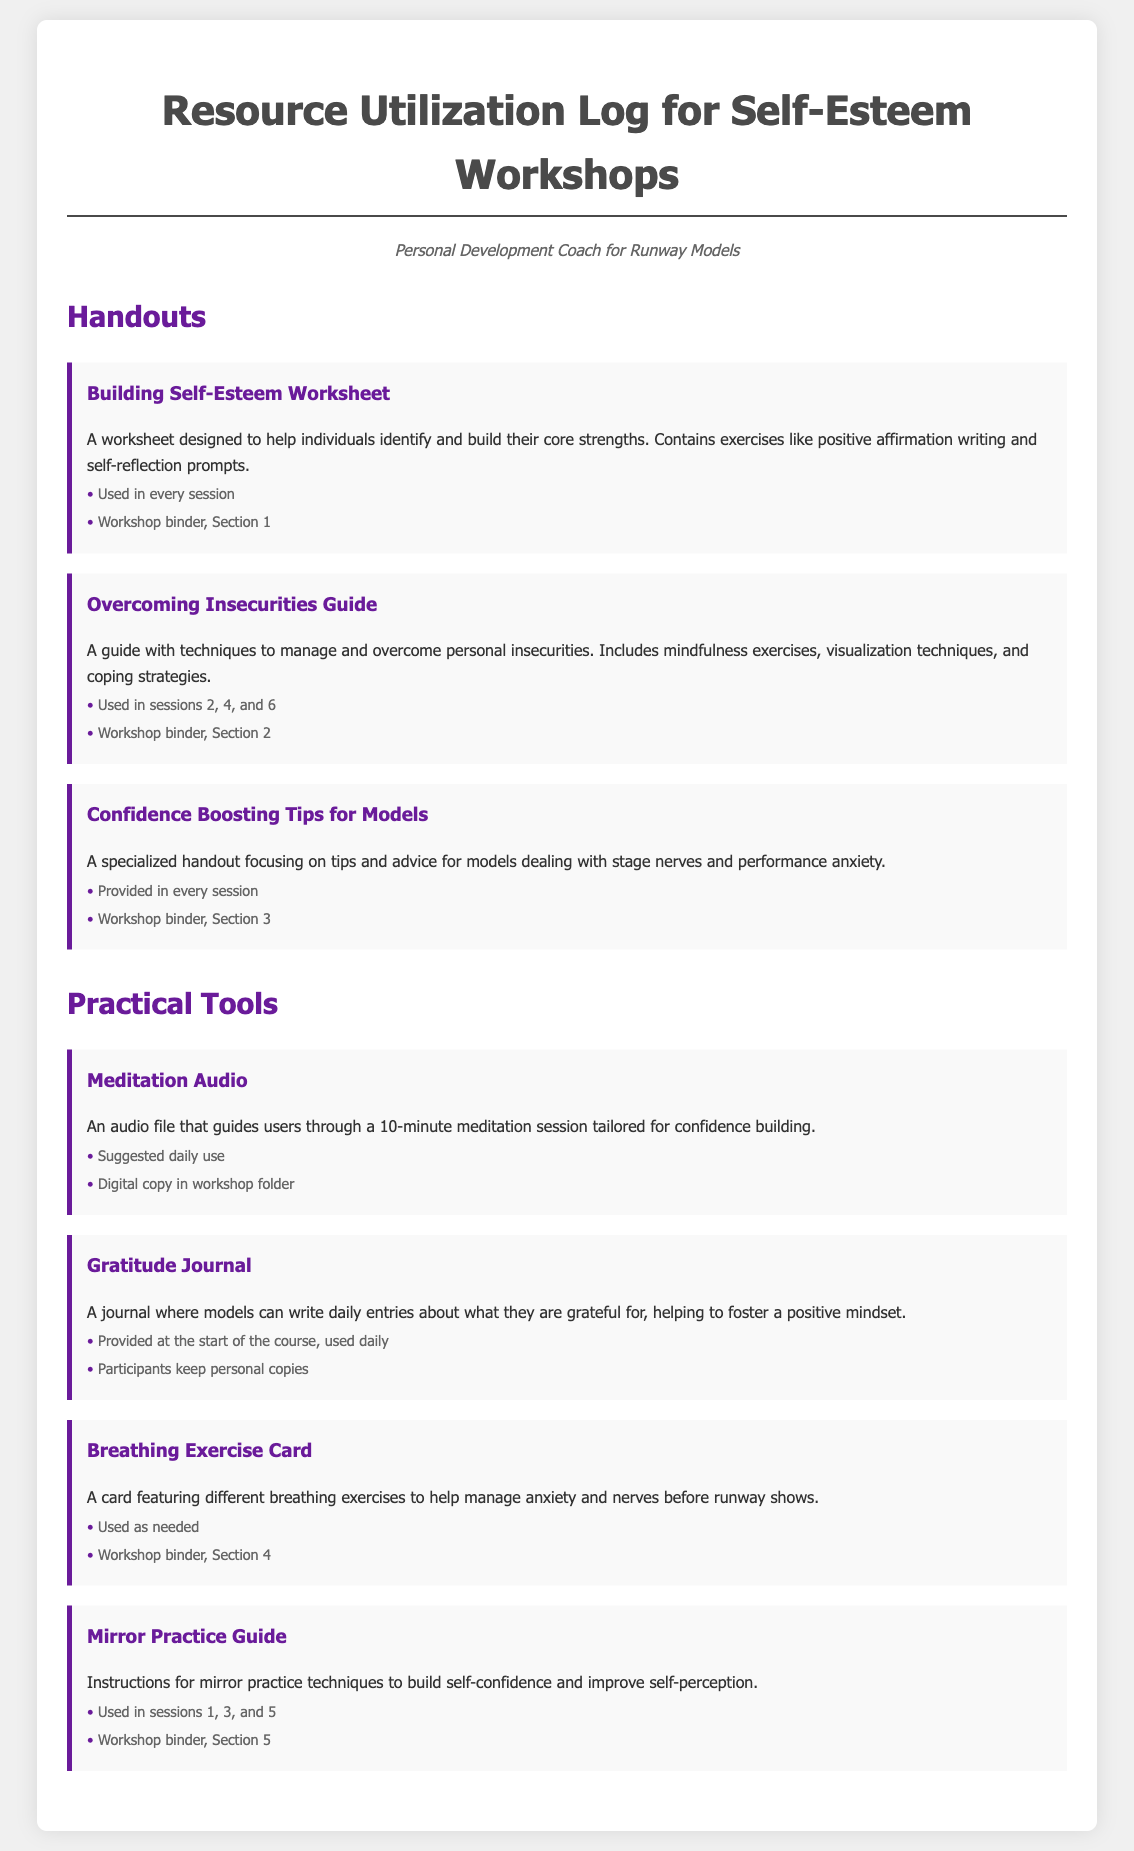what is the title of the first handout? The title of the first handout listed in the document is "Building Self-Esteem Worksheet".
Answer: Building Self-Esteem Worksheet how many sessions is the "Overcoming Insecurities Guide" used in? The guide is used in three specified sessions which are 2, 4, and 6.
Answer: 3 which item is provided at the start of the course? The Gratitude Journal is noted as being provided at the start of the course.
Answer: Gratitude Journal how often should the Meditation Audio be used? The document states that the Meditation Audio is suggested for daily use.
Answer: Daily in which section of the workshop binder is the Breathing Exercise Card stored? The Breathing Exercise Card is stored in Section 4 of the workshop binder.
Answer: Section 4 which practical tool is used in sessions 1, 3, and 5? The tool used in sessions 1, 3, and 5 is the Mirror Practice Guide.
Answer: Mirror Practice Guide what is the main purpose of the "Confidence Boosting Tips for Models"? The main purpose of this handout is to provide tips and advice for models dealing with stage nerves and performance anxiety.
Answer: Tips and advice for models how many handouts are mentioned in the document? The document lists a total of three handouts provided for the self-esteem workshops.
Answer: 3 